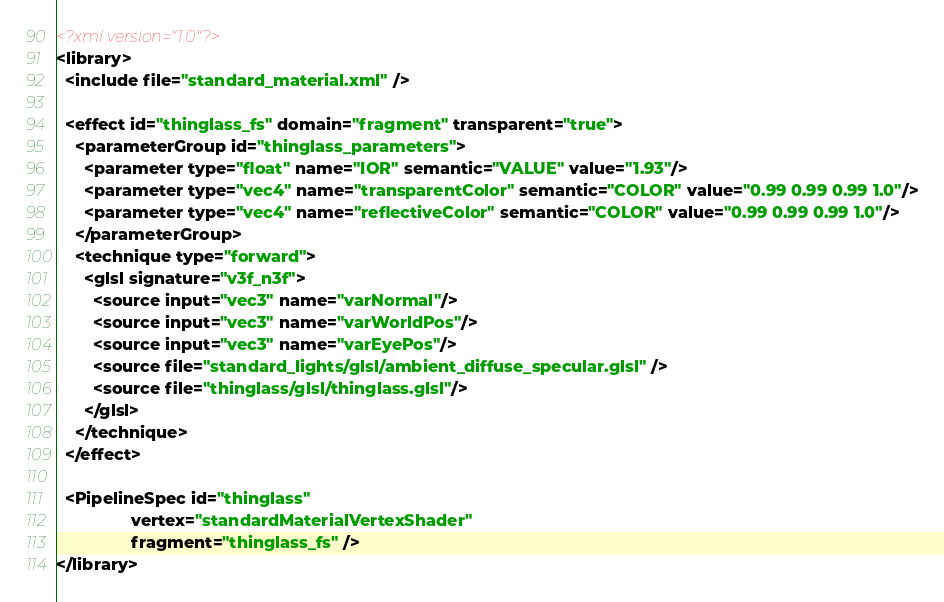<code> <loc_0><loc_0><loc_500><loc_500><_XML_><?xml version="1.0"?>
<library>
  <include file="standard_material.xml" />

  <effect id="thinglass_fs" domain="fragment" transparent="true">
    <parameterGroup id="thinglass_parameters">
      <parameter type="float" name="IOR" semantic="VALUE" value="1.93"/>
      <parameter type="vec4" name="transparentColor" semantic="COLOR" value="0.99 0.99 0.99 1.0"/>
      <parameter type="vec4" name="reflectiveColor" semantic="COLOR" value="0.99 0.99 0.99 1.0"/>
    </parameterGroup>
    <technique type="forward">
      <glsl signature="v3f_n3f">
        <source input="vec3" name="varNormal"/>
        <source input="vec3" name="varWorldPos"/>
        <source input="vec3" name="varEyePos"/>
        <source file="standard_lights/glsl/ambient_diffuse_specular.glsl" />
        <source file="thinglass/glsl/thinglass.glsl"/>
      </glsl>
    </technique>
  </effect>

  <PipelineSpec id="thinglass"
                vertex="standardMaterialVertexShader"
                fragment="thinglass_fs" />
</library>
</code> 